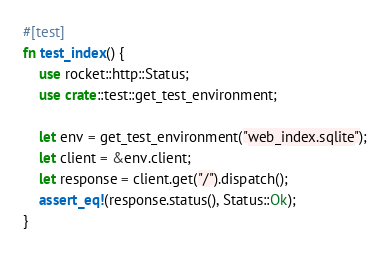<code> <loc_0><loc_0><loc_500><loc_500><_Rust_>
#[test]
fn test_index() {
	use rocket::http::Status;
	use crate::test::get_test_environment;

	let env = get_test_environment("web_index.sqlite");
	let client = &env.client;
	let response = client.get("/").dispatch();
	assert_eq!(response.status(), Status::Ok);
}
</code> 